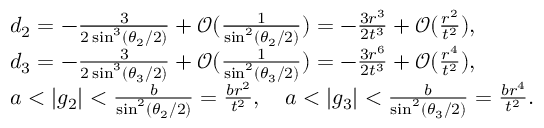Convert formula to latex. <formula><loc_0><loc_0><loc_500><loc_500>\begin{array} { r l } & { d _ { 2 } = - \frac { 3 } { 2 \sin ^ { 3 } ( \theta _ { 2 } / 2 ) } + \mathcal { O } ( \frac { 1 } { \sin ^ { 2 } ( \theta _ { 2 } / 2 ) } ) = - \frac { 3 r ^ { 3 } } { 2 t ^ { 3 } } + \mathcal { O } ( \frac { r ^ { 2 } } { t ^ { 2 } } ) , } \\ & { d _ { 3 } = - \frac { 3 } { 2 \sin ^ { 3 } ( \theta _ { 3 } / 2 ) } + \mathcal { O } ( \frac { 1 } { \sin ^ { 2 } ( \theta _ { 3 } / 2 ) } ) = - \frac { 3 r ^ { 6 } } { 2 t ^ { 3 } } + \mathcal { O } ( \frac { r ^ { 4 } } { t ^ { 2 } } ) , } \\ & { a < | g _ { 2 } | < \frac { b } { \sin ^ { 2 } ( \theta _ { 2 } / 2 ) } = \frac { b r ^ { 2 } } { t ^ { 2 } } , \quad a < | g _ { 3 } | < \frac { b } { \sin ^ { 2 } ( \theta _ { 3 } / 2 ) } = \frac { b r ^ { 4 } } { t ^ { 2 } } . } \end{array}</formula> 